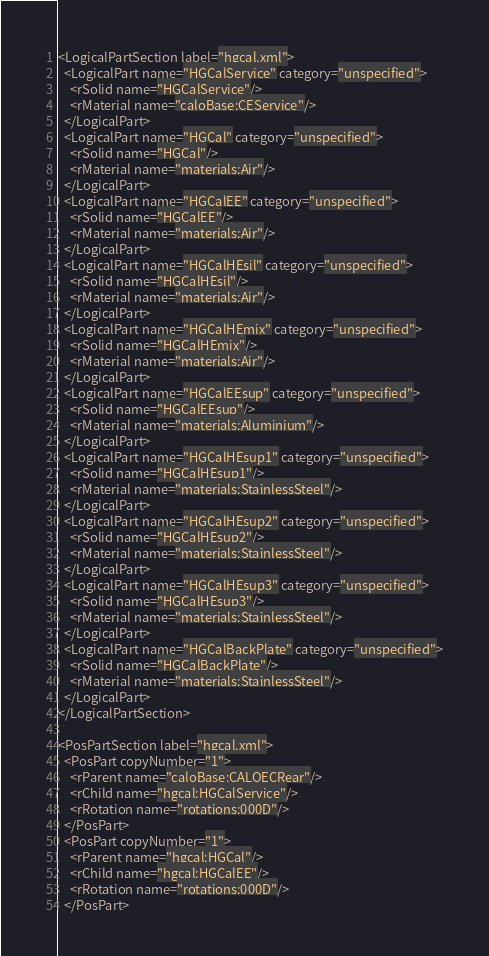<code> <loc_0><loc_0><loc_500><loc_500><_XML_>
<LogicalPartSection label="hgcal.xml">
  <LogicalPart name="HGCalService" category="unspecified">
    <rSolid name="HGCalService"/>
    <rMaterial name="caloBase:CEService"/>
  </LogicalPart>
  <LogicalPart name="HGCal" category="unspecified">
    <rSolid name="HGCal"/>
    <rMaterial name="materials:Air"/>
  </LogicalPart>
  <LogicalPart name="HGCalEE" category="unspecified">
    <rSolid name="HGCalEE"/>
    <rMaterial name="materials:Air"/>
  </LogicalPart>
  <LogicalPart name="HGCalHEsil" category="unspecified">
    <rSolid name="HGCalHEsil"/>
    <rMaterial name="materials:Air"/>
  </LogicalPart>
  <LogicalPart name="HGCalHEmix" category="unspecified">
    <rSolid name="HGCalHEmix"/>
    <rMaterial name="materials:Air"/>
  </LogicalPart>
  <LogicalPart name="HGCalEEsup" category="unspecified">
    <rSolid name="HGCalEEsup"/>
    <rMaterial name="materials:Aluminium"/>
  </LogicalPart>
  <LogicalPart name="HGCalHEsup1" category="unspecified">
    <rSolid name="HGCalHEsup1"/>
    <rMaterial name="materials:StainlessSteel"/>
  </LogicalPart>
  <LogicalPart name="HGCalHEsup2" category="unspecified">
    <rSolid name="HGCalHEsup2"/>
    <rMaterial name="materials:StainlessSteel"/>
  </LogicalPart>
  <LogicalPart name="HGCalHEsup3" category="unspecified">
    <rSolid name="HGCalHEsup3"/>
    <rMaterial name="materials:StainlessSteel"/>
  </LogicalPart>
  <LogicalPart name="HGCalBackPlate" category="unspecified">
    <rSolid name="HGCalBackPlate"/>
    <rMaterial name="materials:StainlessSteel"/>
  </LogicalPart>
</LogicalPartSection>

<PosPartSection label="hgcal.xml">
  <PosPart copyNumber="1">
    <rParent name="caloBase:CALOECRear"/>
    <rChild name="hgcal:HGCalService"/>
    <rRotation name="rotations:000D"/>
  </PosPart>
  <PosPart copyNumber="1">
    <rParent name="hgcal:HGCal"/>
    <rChild name="hgcal:HGCalEE"/>
    <rRotation name="rotations:000D"/>
  </PosPart></code> 